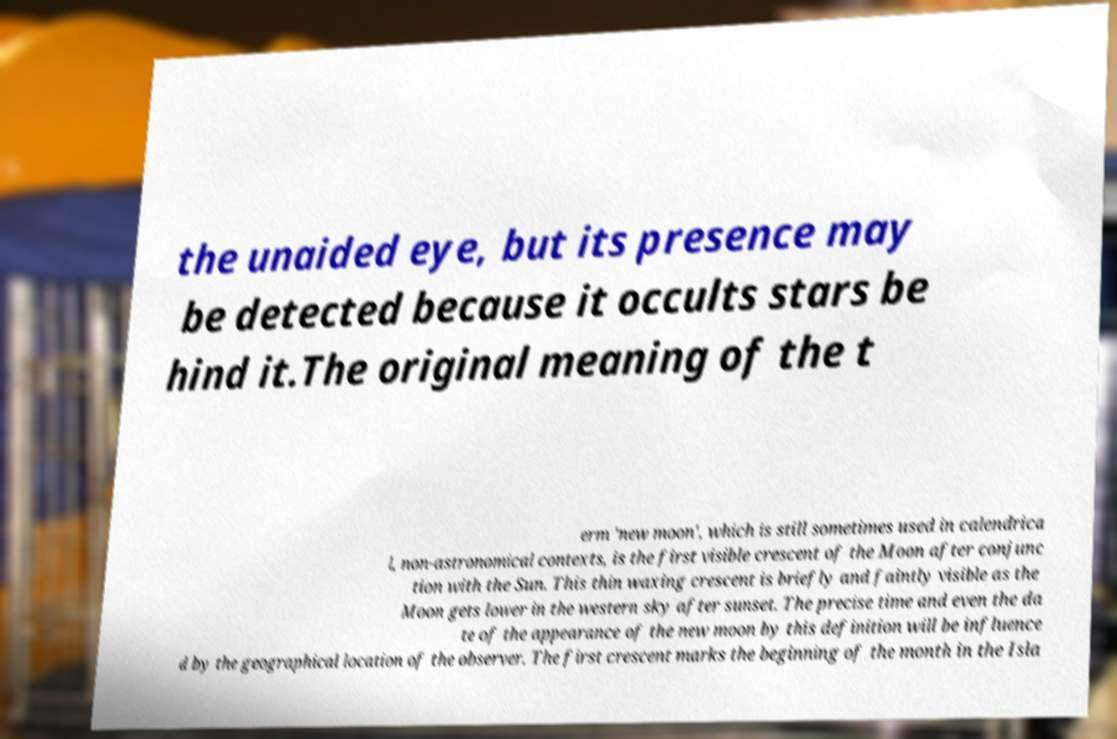Can you accurately transcribe the text from the provided image for me? the unaided eye, but its presence may be detected because it occults stars be hind it.The original meaning of the t erm 'new moon', which is still sometimes used in calendrica l, non-astronomical contexts, is the first visible crescent of the Moon after conjunc tion with the Sun. This thin waxing crescent is briefly and faintly visible as the Moon gets lower in the western sky after sunset. The precise time and even the da te of the appearance of the new moon by this definition will be influence d by the geographical location of the observer. The first crescent marks the beginning of the month in the Isla 